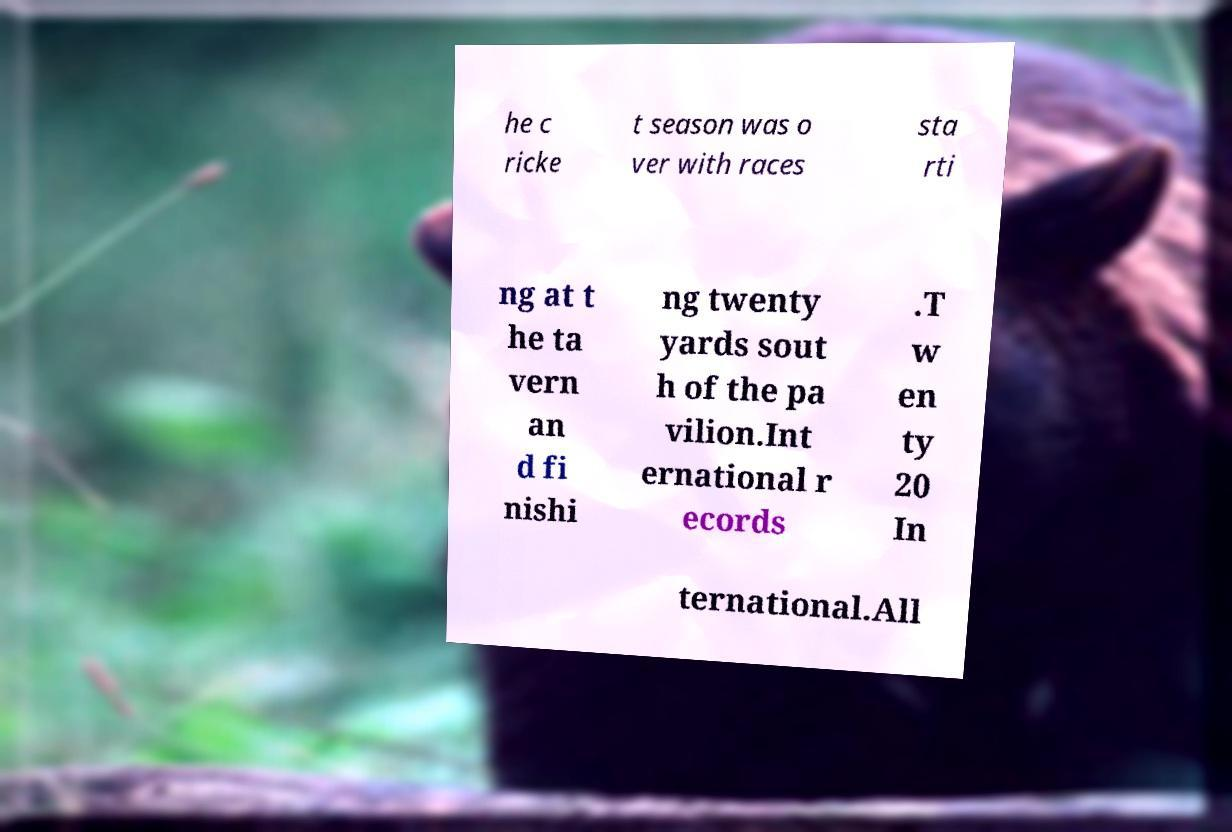Can you read and provide the text displayed in the image?This photo seems to have some interesting text. Can you extract and type it out for me? he c ricke t season was o ver with races sta rti ng at t he ta vern an d fi nishi ng twenty yards sout h of the pa vilion.Int ernational r ecords .T w en ty 20 In ternational.All 